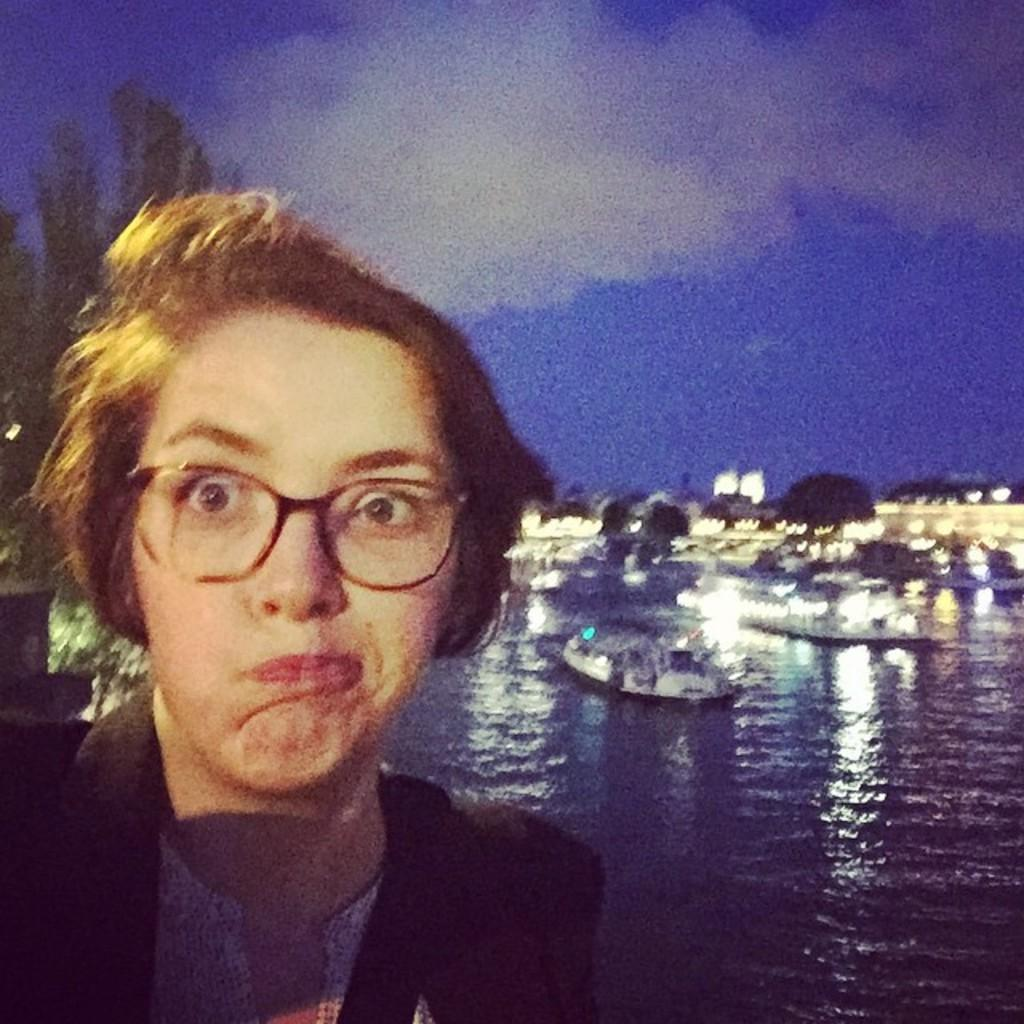Who is the main subject in the foreground of the image? There is a lady in the foreground of the image. What can be seen in the background of the image? In the background of the image, there is water, ships, buildings, sky, and trees. Can you describe the setting of the image? The image appears to be set near a body of water, with ships and buildings visible in the distance. Trees and sky are also visible in the background. What type of snake can be seen slithering through the dust in the image? There is no snake or dust present in the image. The image features a lady in the foreground and a background setting with water, ships, buildings, sky, and trees. 